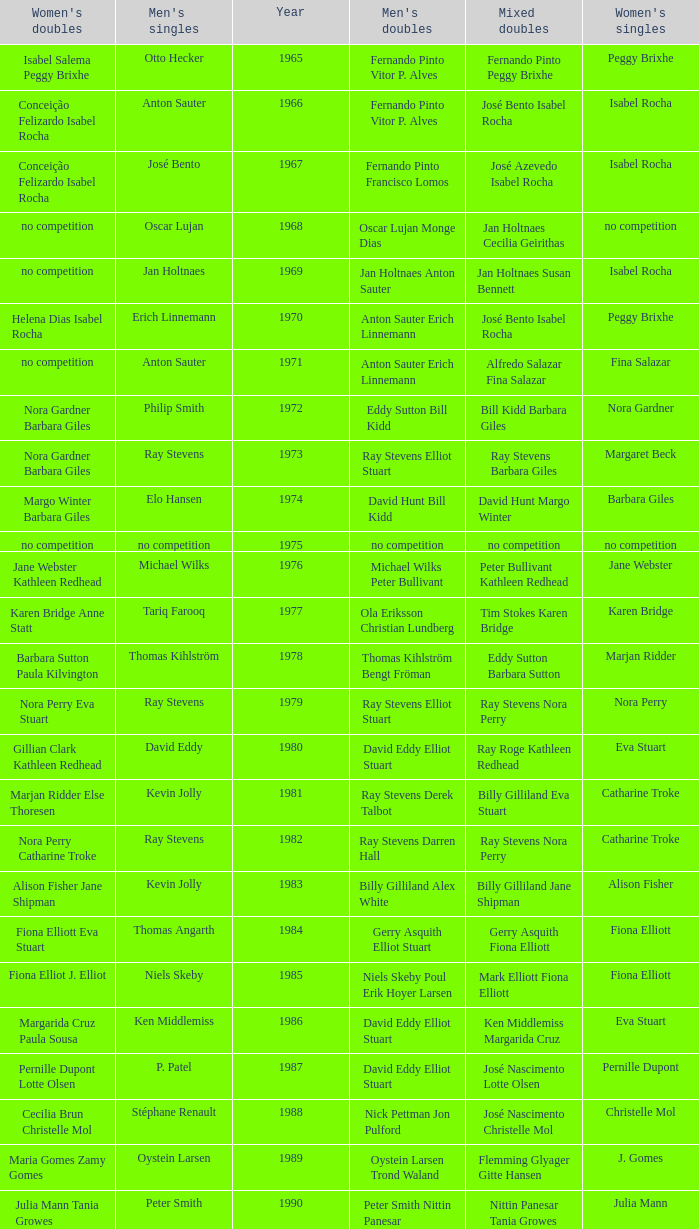Which women's doubles happened after 1987 and a women's single of astrid van der knaap? Elena Denisova Marina Yakusheva. 